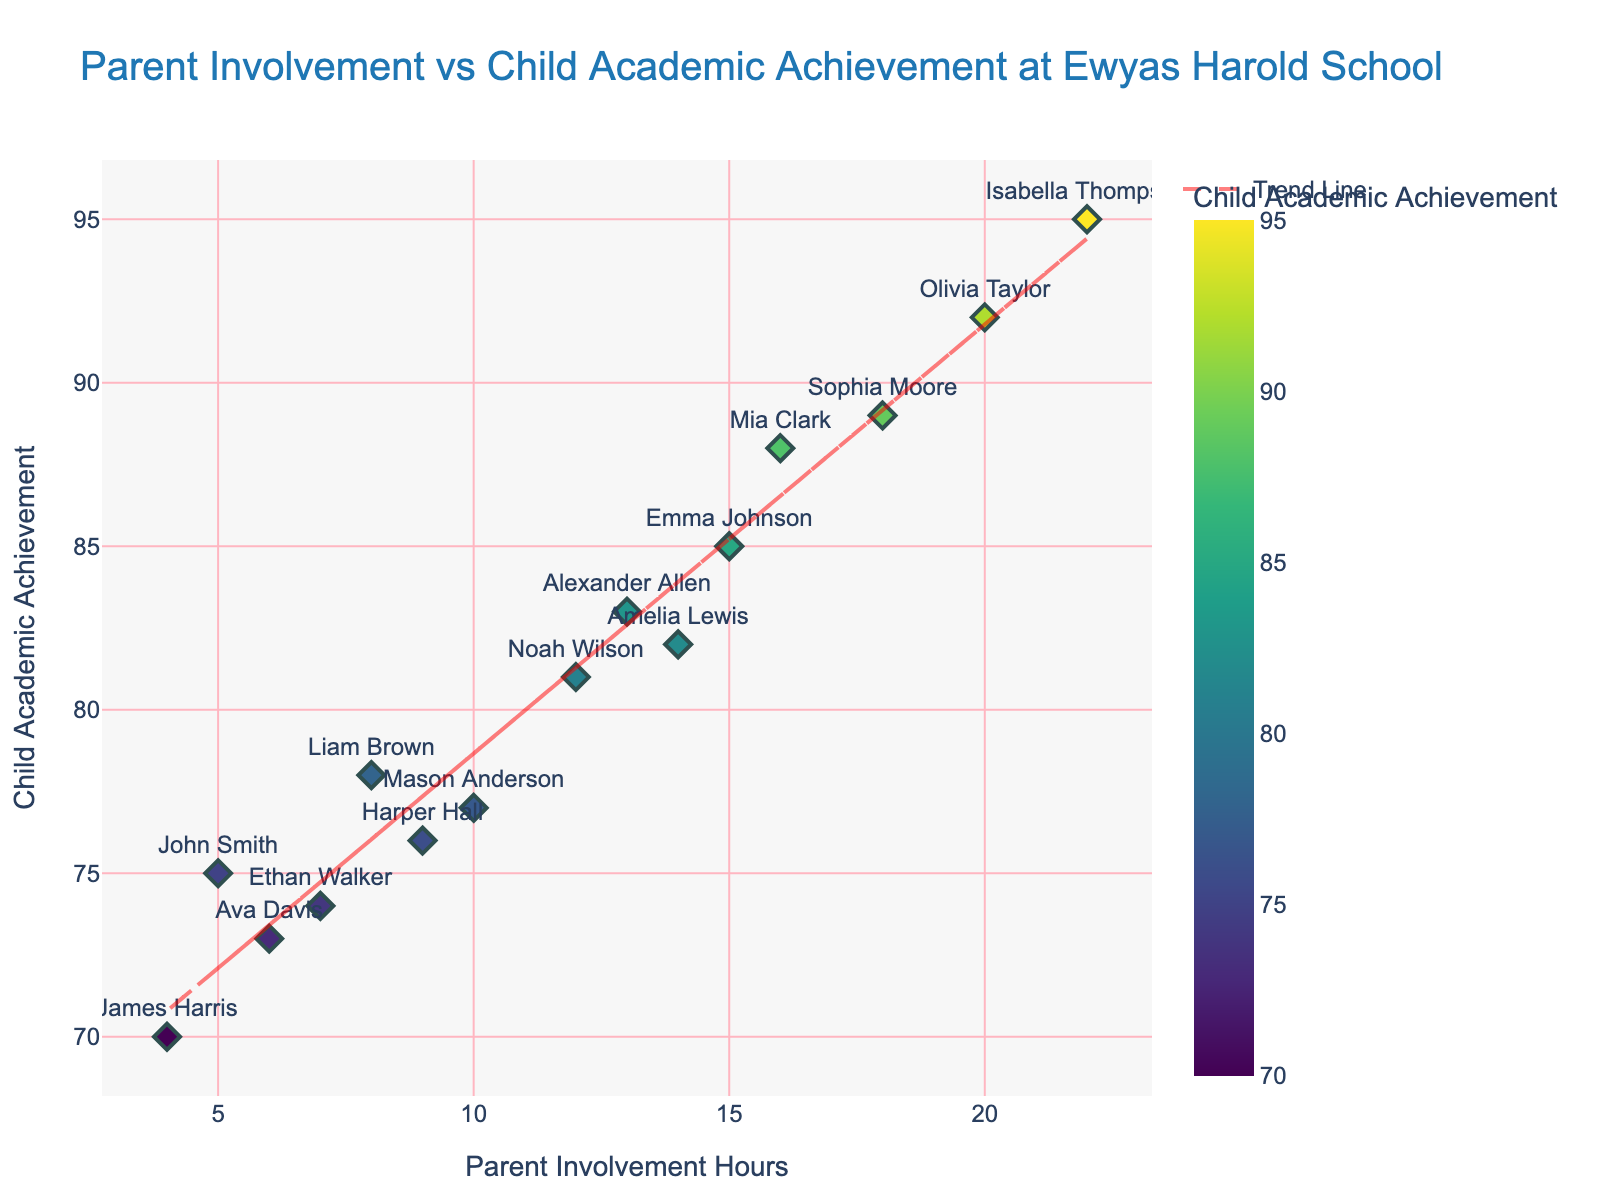What is the title of the figure? The title is typically found at the top of the figure and describes what the plot represents.
Answer: Parent Involvement vs Child Academic Achievement at Ewyas Harold School How many data points are shown in the figure? Count the number of visible points on the scatter plot. Each point represents one data point.
Answer: 15 What is the range of Parent Involvement Hours on the x-axis? Look at the minimum and maximum values shown on the x-axis to determine the range.
Answer: 4 to 22 What is the range of Child Academic Achievement Scores on the y-axis? Look at the minimum and maximum values shown on the y-axis to determine the range.
Answer: 70 to 95 Which parent has the highest Child Academic Achievement score for their child? Identify the point that is highest on the y-axis and check the hover information or text label for the parent’s name.
Answer: Isabella Thompson What is the trend line equation shown in the figure? The trend line is typically drawn as a straight line with an accompanying equation. The equation can often be approximated based on the trend.
Answer: (Assumed as not providing the exact equation as it is not visually provided) Is there a general trend between Parent Involvement Hours and Child Academic Achievement? Observe the overall direction of the trend line to determine the relationship between involvement hours and academic achievement.
Answer: Positive correlation What is the average Child Academic Achievement score for children of parents with 10 or more involvement hours? Identify the points where Parent Involvement Hours are 10 or higher, sum their Child Academic Achievement scores, and divide by the number of these points.
Answer: (85 + 92 + 81 + 89 + 95 + 88 + 82 + 83)/8 = 82.625 Which parent has the lowest Child Academic Achievement score for their child? Identify the point that is lowest on the y-axis and check the hover information or text label for the parent’s name.
Answer: James Harris What is the difference in Child Academic Achievement score between the parents with the highest and lowest involvement hours? Find the points with the highest and lowest x-values, note their y-values, and then calculate the difference.
Answer: (Child Academic Achievement of Isabella Thompson) - (Child Academic Achievement of James Harris) = 95 - 70 = 25 